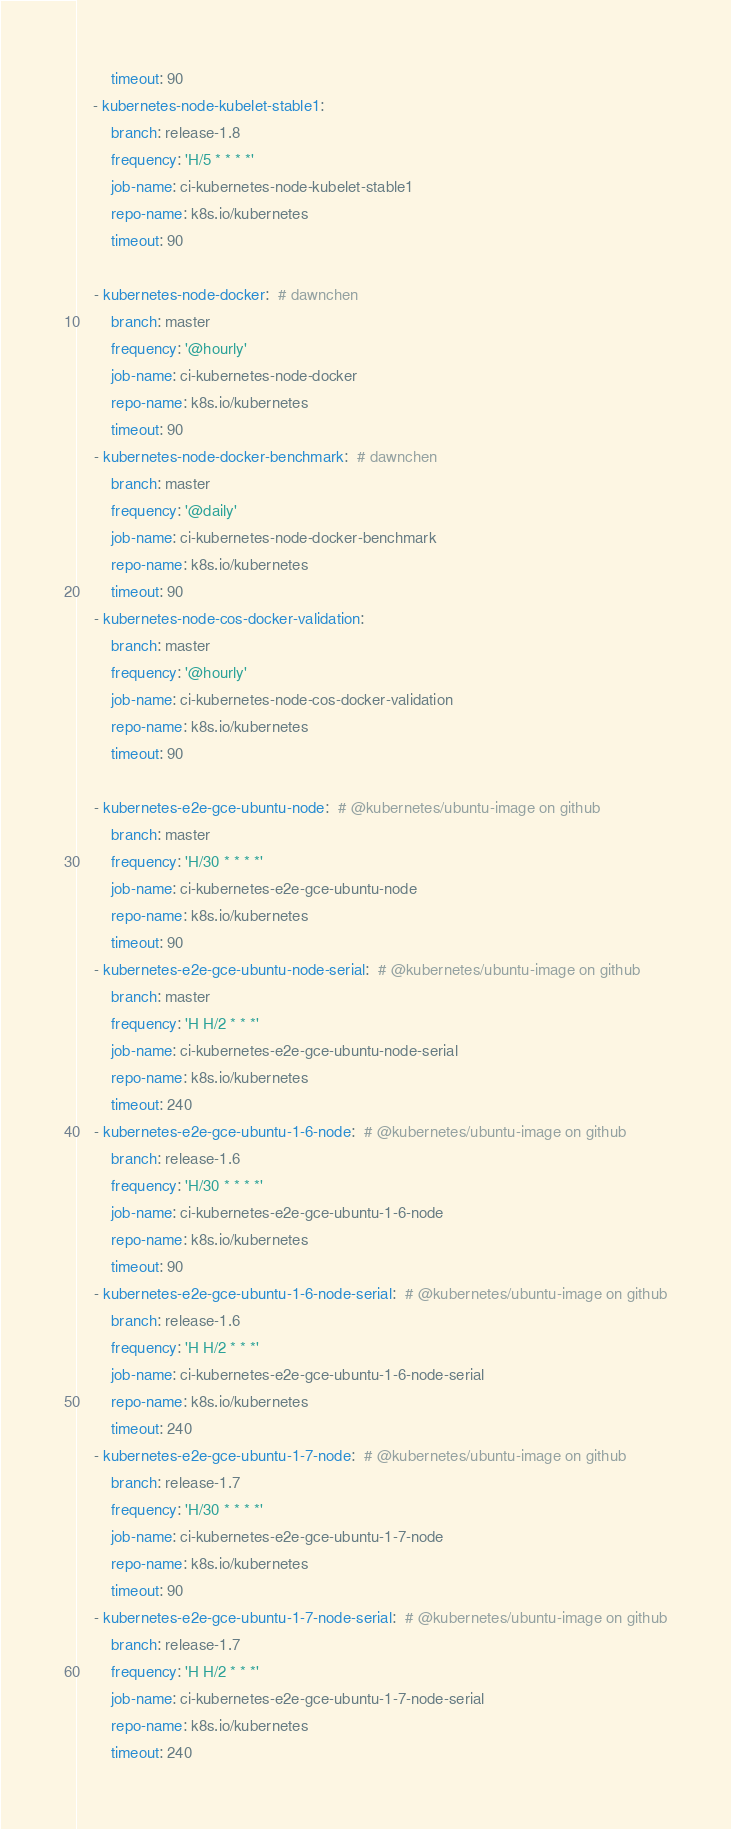Convert code to text. <code><loc_0><loc_0><loc_500><loc_500><_YAML_>        timeout: 90
    - kubernetes-node-kubelet-stable1:
        branch: release-1.8
        frequency: 'H/5 * * * *'
        job-name: ci-kubernetes-node-kubelet-stable1
        repo-name: k8s.io/kubernetes
        timeout: 90

    - kubernetes-node-docker:  # dawnchen
        branch: master
        frequency: '@hourly'
        job-name: ci-kubernetes-node-docker
        repo-name: k8s.io/kubernetes
        timeout: 90
    - kubernetes-node-docker-benchmark:  # dawnchen
        branch: master
        frequency: '@daily'
        job-name: ci-kubernetes-node-docker-benchmark
        repo-name: k8s.io/kubernetes
        timeout: 90
    - kubernetes-node-cos-docker-validation:  
        branch: master
        frequency: '@hourly'
        job-name: ci-kubernetes-node-cos-docker-validation
        repo-name: k8s.io/kubernetes
        timeout: 90

    - kubernetes-e2e-gce-ubuntu-node:  # @kubernetes/ubuntu-image on github
        branch: master
        frequency: 'H/30 * * * *'
        job-name: ci-kubernetes-e2e-gce-ubuntu-node
        repo-name: k8s.io/kubernetes
        timeout: 90
    - kubernetes-e2e-gce-ubuntu-node-serial:  # @kubernetes/ubuntu-image on github
        branch: master
        frequency: 'H H/2 * * *'
        job-name: ci-kubernetes-e2e-gce-ubuntu-node-serial
        repo-name: k8s.io/kubernetes
        timeout: 240
    - kubernetes-e2e-gce-ubuntu-1-6-node:  # @kubernetes/ubuntu-image on github
        branch: release-1.6
        frequency: 'H/30 * * * *'
        job-name: ci-kubernetes-e2e-gce-ubuntu-1-6-node
        repo-name: k8s.io/kubernetes
        timeout: 90
    - kubernetes-e2e-gce-ubuntu-1-6-node-serial:  # @kubernetes/ubuntu-image on github
        branch: release-1.6
        frequency: 'H H/2 * * *'
        job-name: ci-kubernetes-e2e-gce-ubuntu-1-6-node-serial
        repo-name: k8s.io/kubernetes
        timeout: 240
    - kubernetes-e2e-gce-ubuntu-1-7-node:  # @kubernetes/ubuntu-image on github
        branch: release-1.7
        frequency: 'H/30 * * * *'
        job-name: ci-kubernetes-e2e-gce-ubuntu-1-7-node
        repo-name: k8s.io/kubernetes
        timeout: 90
    - kubernetes-e2e-gce-ubuntu-1-7-node-serial:  # @kubernetes/ubuntu-image on github
        branch: release-1.7
        frequency: 'H H/2 * * *'
        job-name: ci-kubernetes-e2e-gce-ubuntu-1-7-node-serial
        repo-name: k8s.io/kubernetes
        timeout: 240
</code> 